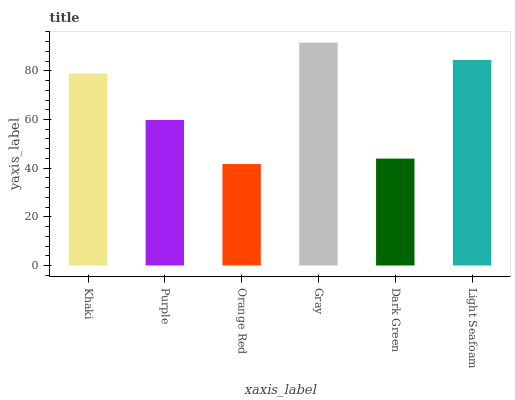Is Orange Red the minimum?
Answer yes or no. Yes. Is Gray the maximum?
Answer yes or no. Yes. Is Purple the minimum?
Answer yes or no. No. Is Purple the maximum?
Answer yes or no. No. Is Khaki greater than Purple?
Answer yes or no. Yes. Is Purple less than Khaki?
Answer yes or no. Yes. Is Purple greater than Khaki?
Answer yes or no. No. Is Khaki less than Purple?
Answer yes or no. No. Is Khaki the high median?
Answer yes or no. Yes. Is Purple the low median?
Answer yes or no. Yes. Is Dark Green the high median?
Answer yes or no. No. Is Orange Red the low median?
Answer yes or no. No. 